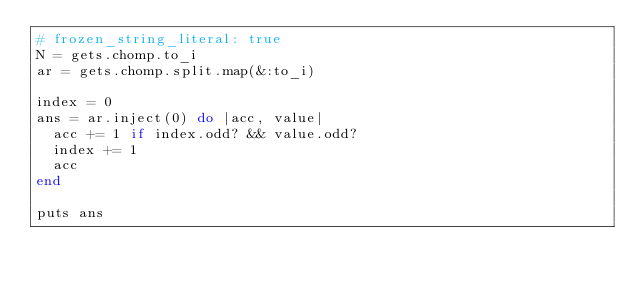Convert code to text. <code><loc_0><loc_0><loc_500><loc_500><_Ruby_># frozen_string_literal: true
N = gets.chomp.to_i
ar = gets.chomp.split.map(&:to_i)

index = 0
ans = ar.inject(0) do |acc, value|
  acc += 1 if index.odd? && value.odd?
  index += 1
  acc
end

puts ans
</code> 